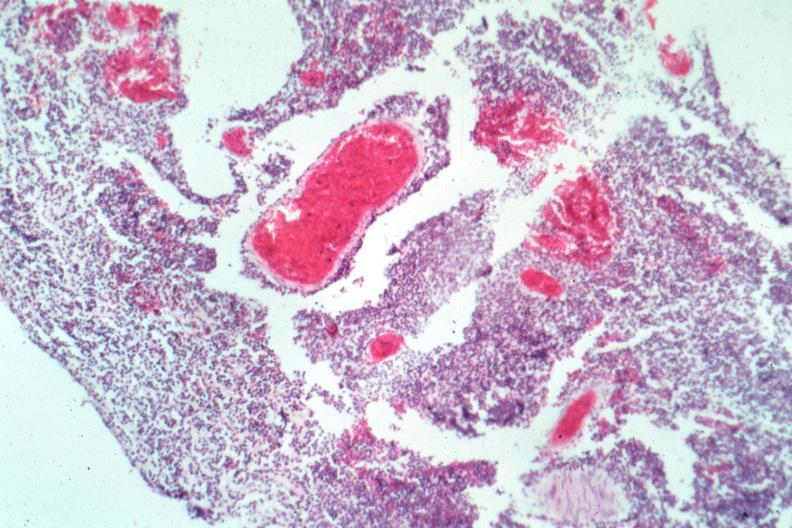what is present?
Answer the question using a single word or phrase. Meningitis acute 